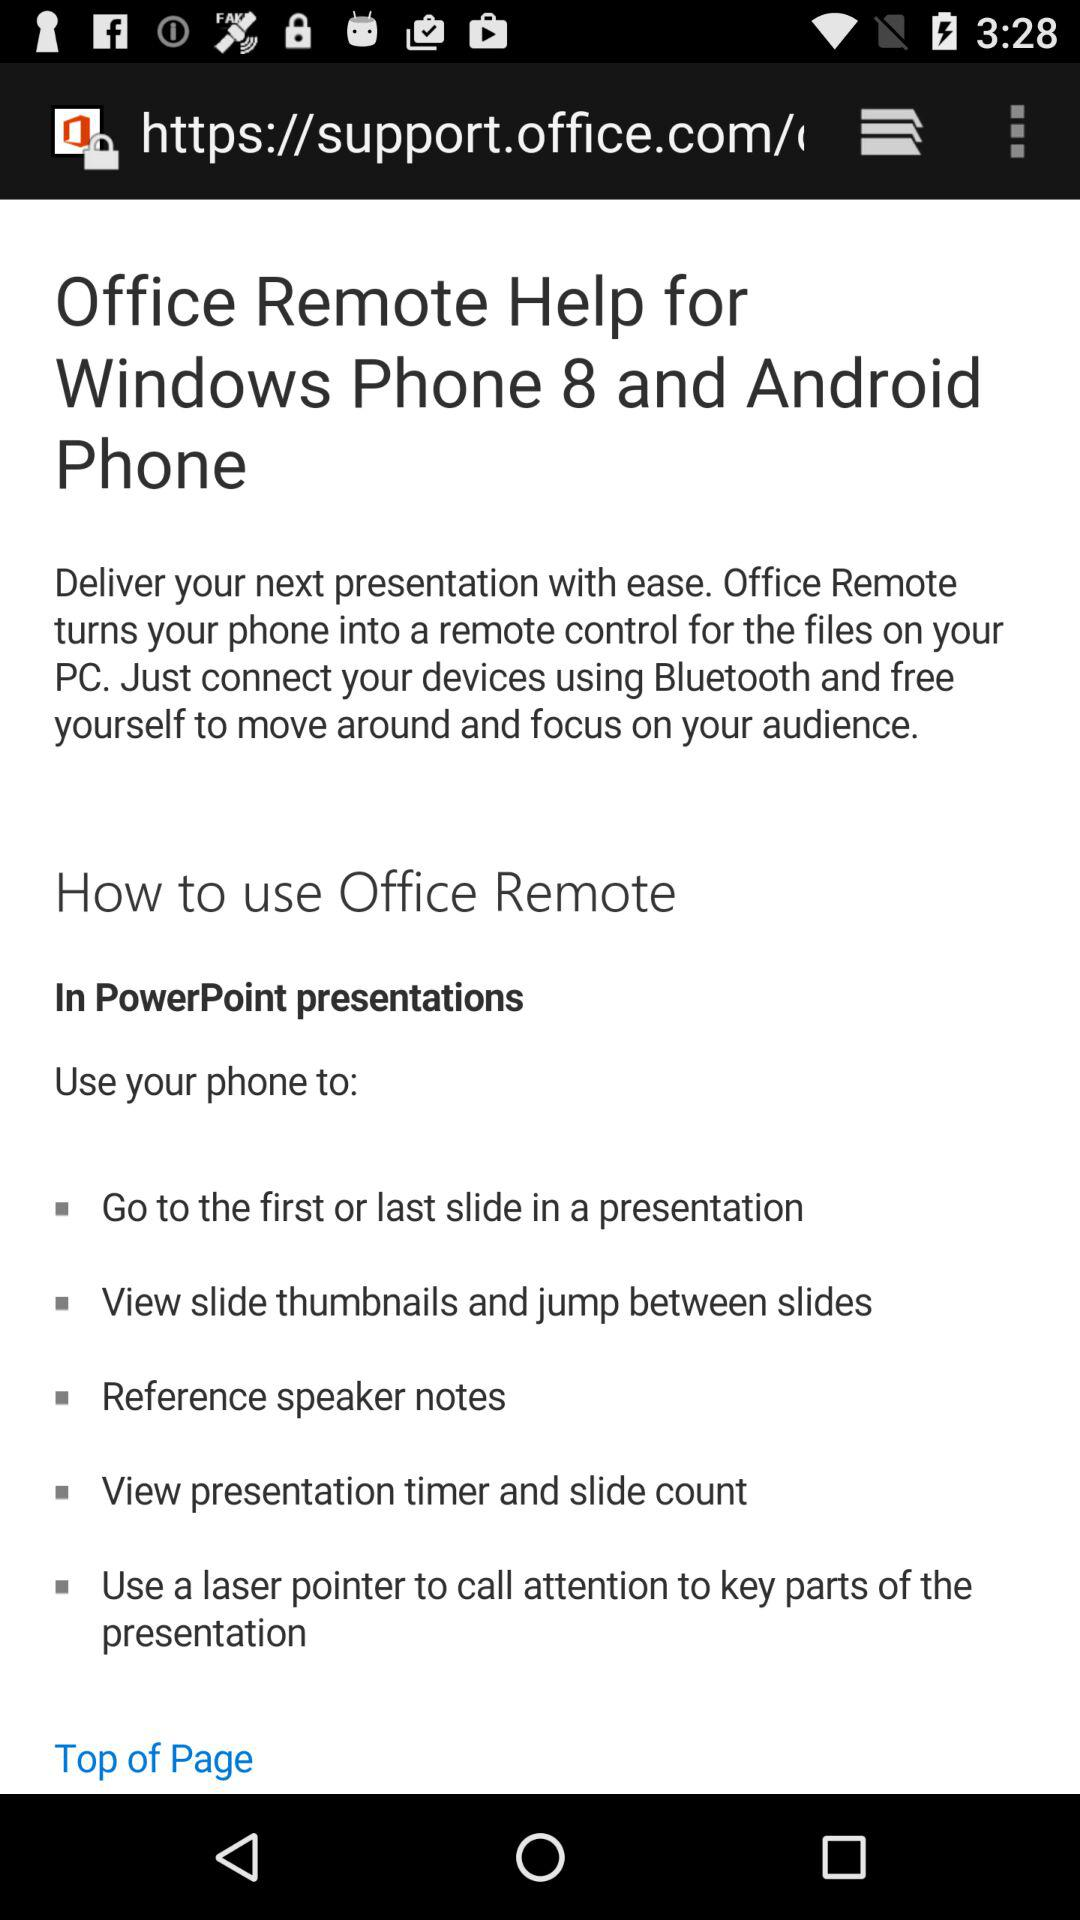What is the name of application? The application name is "Office Remote". 